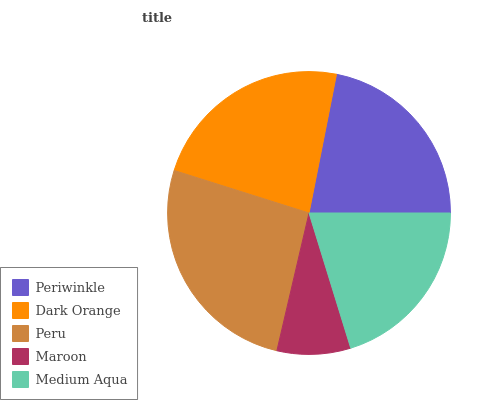Is Maroon the minimum?
Answer yes or no. Yes. Is Peru the maximum?
Answer yes or no. Yes. Is Dark Orange the minimum?
Answer yes or no. No. Is Dark Orange the maximum?
Answer yes or no. No. Is Dark Orange greater than Periwinkle?
Answer yes or no. Yes. Is Periwinkle less than Dark Orange?
Answer yes or no. Yes. Is Periwinkle greater than Dark Orange?
Answer yes or no. No. Is Dark Orange less than Periwinkle?
Answer yes or no. No. Is Periwinkle the high median?
Answer yes or no. Yes. Is Periwinkle the low median?
Answer yes or no. Yes. Is Peru the high median?
Answer yes or no. No. Is Medium Aqua the low median?
Answer yes or no. No. 